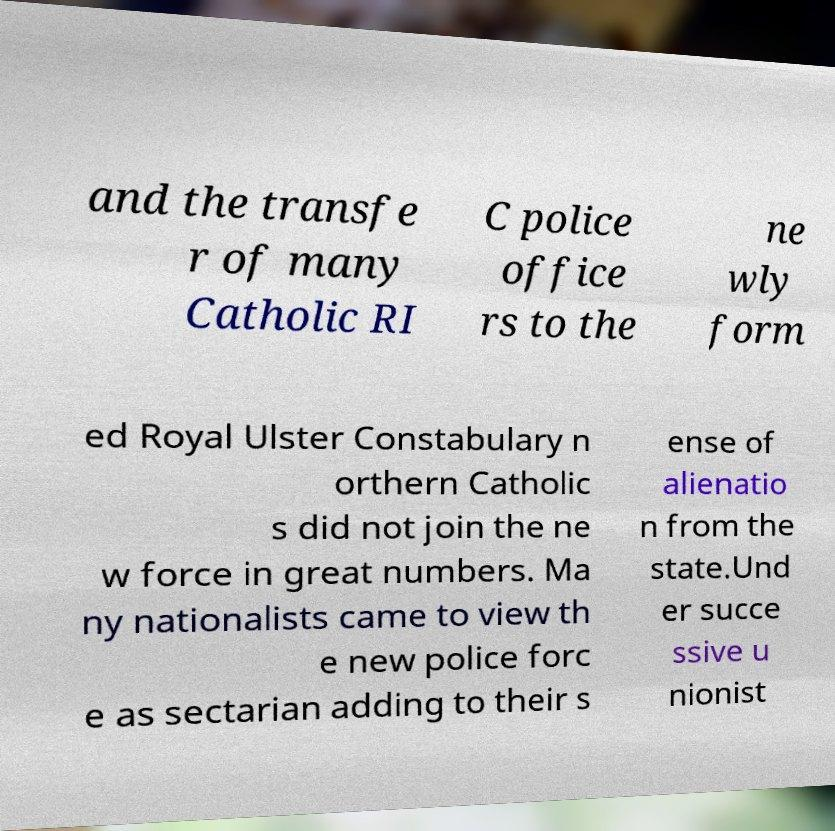Can you read and provide the text displayed in the image?This photo seems to have some interesting text. Can you extract and type it out for me? and the transfe r of many Catholic RI C police office rs to the ne wly form ed Royal Ulster Constabulary n orthern Catholic s did not join the ne w force in great numbers. Ma ny nationalists came to view th e new police forc e as sectarian adding to their s ense of alienatio n from the state.Und er succe ssive u nionist 